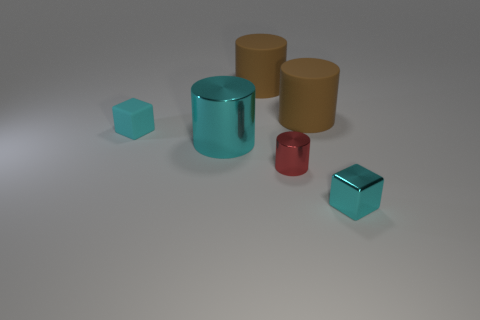Can you tell which one of these objects is the heaviest based purely on this image? While an image alone doesn't provide enough information to determine exact weights, we can make an educated guess. Typically, objects made of metal tend to be heavier. If any of these objects are metal, that might be the heaviest. 